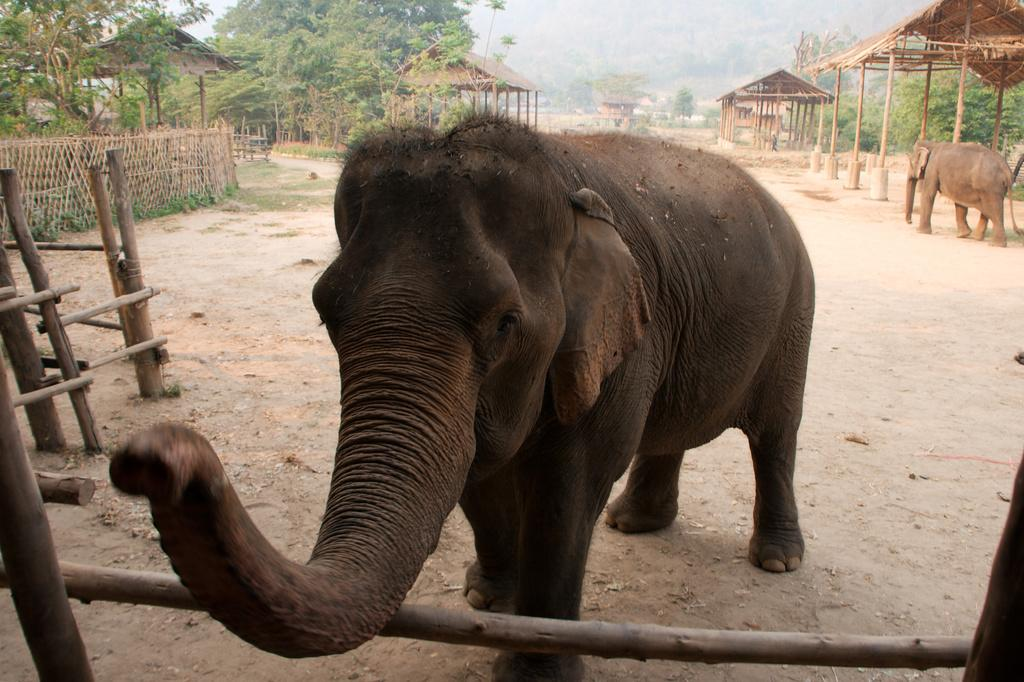What is the setting of the image? The image has an outside view. What is the main subject in the middle of the image? There is an elephant in the middle of the image. What can be seen in the background of the image? There are trees and huts in the background of the image. How many flies can be seen pasting themselves on the elephant in the image? There are no flies present in the image, and therefore no such activity can be observed. 